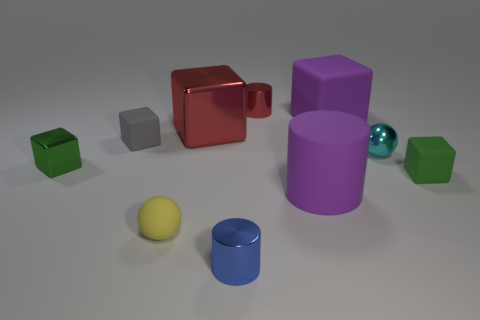What material is the green object left of the tiny metal cylinder behind the yellow matte sphere made of?
Your answer should be very brief. Metal. What is the size of the purple matte object that is the same shape as the large red object?
Give a very brief answer. Large. Does the matte cube that is on the left side of the large red shiny block have the same color as the matte ball?
Ensure brevity in your answer.  No. Is the number of matte cubes less than the number of cyan metallic things?
Your answer should be very brief. No. What number of other things are the same color as the large metal block?
Your response must be concise. 1. Does the cylinder in front of the matte ball have the same material as the large purple cylinder?
Offer a terse response. No. There is a green block right of the small metallic cube; what is its material?
Offer a very short reply. Rubber. How big is the purple matte thing behind the cyan shiny sphere that is behind the tiny blue object?
Make the answer very short. Large. Is there a purple block made of the same material as the big cylinder?
Offer a very short reply. Yes. The small green object that is behind the green block on the right side of the red shiny thing that is behind the red block is what shape?
Keep it short and to the point. Cube. 